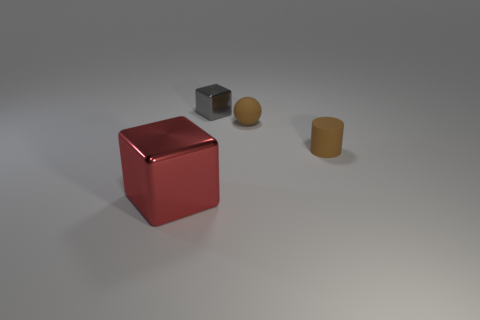There is a metal thing left of the metallic thing to the right of the red metal object; what shape is it?
Make the answer very short. Cube. Does the red object have the same size as the brown object that is behind the brown cylinder?
Give a very brief answer. No. There is a brown matte sphere that is to the right of the shiny thing that is behind the object that is on the left side of the gray shiny thing; what is its size?
Make the answer very short. Small. What number of things are tiny brown cylinders on the right side of the brown matte sphere or small cyan rubber cylinders?
Offer a very short reply. 1. What number of brown matte spheres are behind the shiny block that is in front of the small cube?
Offer a terse response. 1. Are there more small cylinders in front of the big cube than tiny brown cylinders?
Provide a short and direct response. No. What size is the thing that is in front of the tiny brown ball and left of the rubber cylinder?
Ensure brevity in your answer.  Large. There is a small object that is both to the left of the matte cylinder and in front of the small gray metal object; what is its shape?
Your answer should be very brief. Sphere. Is there a small cylinder behind the tiny brown object right of the tiny brown thing behind the rubber cylinder?
Offer a very short reply. No. What number of objects are either objects in front of the gray shiny block or cubes that are right of the red shiny block?
Keep it short and to the point. 4. 